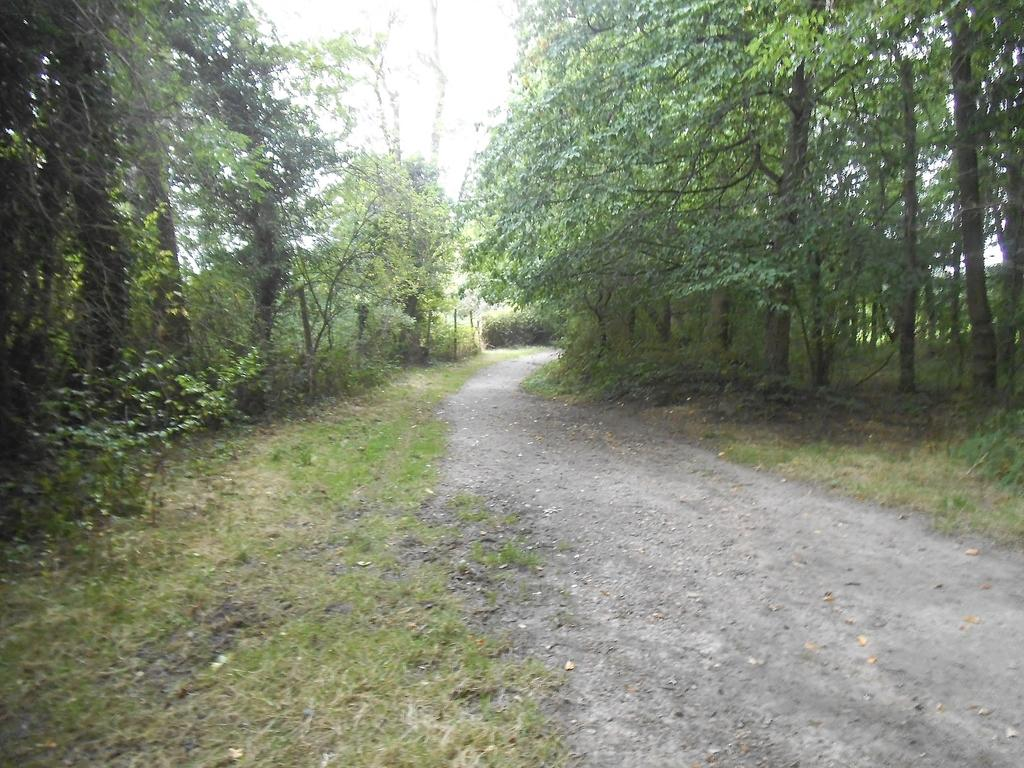What is the main feature in the middle of the image? There is a path in the middle of the image. What type of vegetation is present on either side of the path? There are trees on either side of the path. What is visible at the top of the image? The sky is visible at the top of the image. What type of skate is being used on the path in the image? There is no skate present in the image; it features a path with trees on either side and the sky visible at the top. 